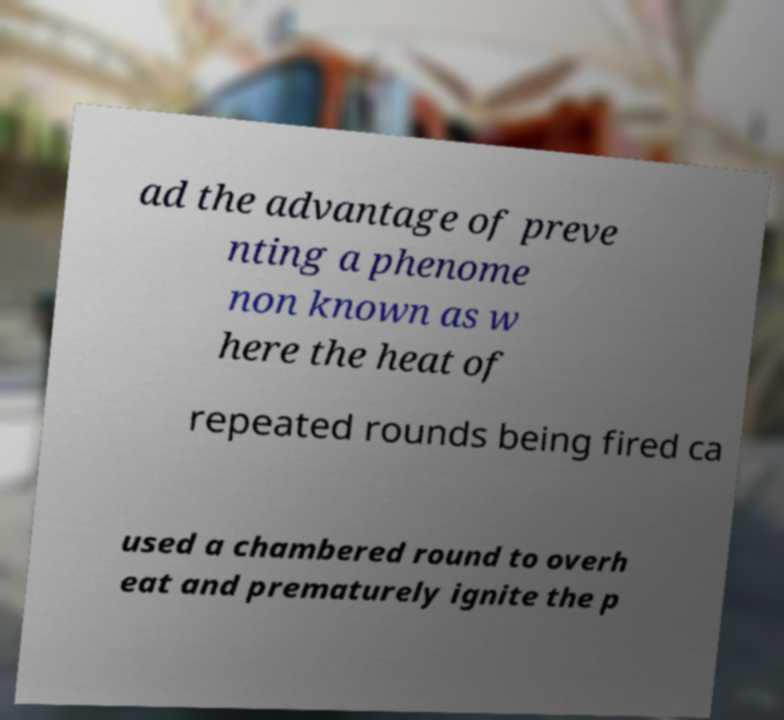Please read and relay the text visible in this image. What does it say? ad the advantage of preve nting a phenome non known as w here the heat of repeated rounds being fired ca used a chambered round to overh eat and prematurely ignite the p 